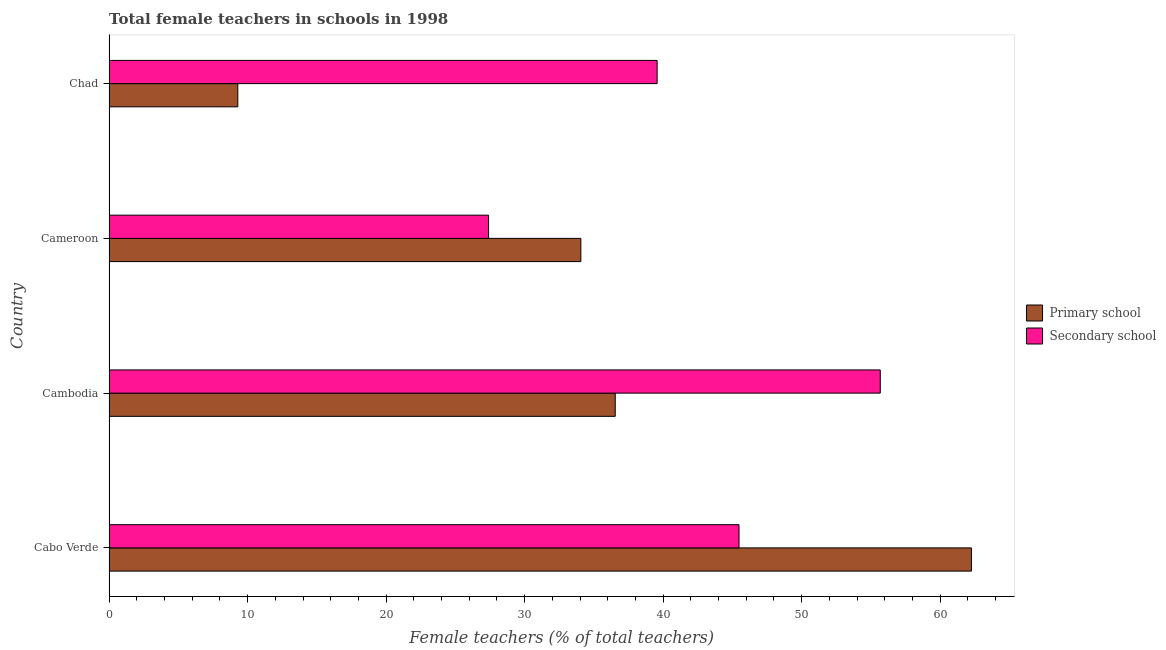Are the number of bars on each tick of the Y-axis equal?
Offer a very short reply. Yes. How many bars are there on the 2nd tick from the top?
Provide a short and direct response. 2. How many bars are there on the 3rd tick from the bottom?
Offer a very short reply. 2. What is the label of the 2nd group of bars from the top?
Your response must be concise. Cameroon. In how many cases, is the number of bars for a given country not equal to the number of legend labels?
Make the answer very short. 0. What is the percentage of female teachers in secondary schools in Cambodia?
Your response must be concise. 55.67. Across all countries, what is the maximum percentage of female teachers in primary schools?
Ensure brevity in your answer.  62.26. Across all countries, what is the minimum percentage of female teachers in secondary schools?
Offer a terse response. 27.4. In which country was the percentage of female teachers in secondary schools maximum?
Provide a short and direct response. Cambodia. In which country was the percentage of female teachers in secondary schools minimum?
Your answer should be very brief. Cameroon. What is the total percentage of female teachers in secondary schools in the graph?
Your answer should be compact. 168.12. What is the difference between the percentage of female teachers in primary schools in Cabo Verde and that in Cameroon?
Ensure brevity in your answer.  28.2. What is the difference between the percentage of female teachers in secondary schools in Chad and the percentage of female teachers in primary schools in Cabo Verde?
Keep it short and to the point. -22.69. What is the average percentage of female teachers in primary schools per country?
Give a very brief answer. 35.54. What is the difference between the percentage of female teachers in primary schools and percentage of female teachers in secondary schools in Cabo Verde?
Ensure brevity in your answer.  16.78. In how many countries, is the percentage of female teachers in primary schools greater than 14 %?
Offer a very short reply. 3. What is the ratio of the percentage of female teachers in secondary schools in Cabo Verde to that in Cambodia?
Provide a short and direct response. 0.82. Is the percentage of female teachers in primary schools in Cabo Verde less than that in Cambodia?
Give a very brief answer. No. What is the difference between the highest and the second highest percentage of female teachers in secondary schools?
Offer a very short reply. 10.2. What is the difference between the highest and the lowest percentage of female teachers in secondary schools?
Keep it short and to the point. 28.28. In how many countries, is the percentage of female teachers in primary schools greater than the average percentage of female teachers in primary schools taken over all countries?
Your answer should be very brief. 2. What does the 1st bar from the top in Cameroon represents?
Your response must be concise. Secondary school. What does the 2nd bar from the bottom in Cabo Verde represents?
Ensure brevity in your answer.  Secondary school. How many countries are there in the graph?
Keep it short and to the point. 4. What is the difference between two consecutive major ticks on the X-axis?
Provide a succinct answer. 10. Does the graph contain grids?
Give a very brief answer. No. Where does the legend appear in the graph?
Provide a succinct answer. Center right. How are the legend labels stacked?
Your answer should be compact. Vertical. What is the title of the graph?
Your answer should be very brief. Total female teachers in schools in 1998. Does "Borrowers" appear as one of the legend labels in the graph?
Ensure brevity in your answer.  No. What is the label or title of the X-axis?
Your answer should be compact. Female teachers (% of total teachers). What is the Female teachers (% of total teachers) of Primary school in Cabo Verde?
Offer a very short reply. 62.26. What is the Female teachers (% of total teachers) of Secondary school in Cabo Verde?
Your answer should be very brief. 45.48. What is the Female teachers (% of total teachers) in Primary school in Cambodia?
Provide a short and direct response. 36.54. What is the Female teachers (% of total teachers) of Secondary school in Cambodia?
Provide a succinct answer. 55.67. What is the Female teachers (% of total teachers) in Primary school in Cameroon?
Your answer should be very brief. 34.06. What is the Female teachers (% of total teachers) of Secondary school in Cameroon?
Provide a short and direct response. 27.4. What is the Female teachers (% of total teachers) in Primary school in Chad?
Give a very brief answer. 9.29. What is the Female teachers (% of total teachers) of Secondary school in Chad?
Keep it short and to the point. 39.57. Across all countries, what is the maximum Female teachers (% of total teachers) in Primary school?
Offer a terse response. 62.26. Across all countries, what is the maximum Female teachers (% of total teachers) in Secondary school?
Offer a terse response. 55.67. Across all countries, what is the minimum Female teachers (% of total teachers) of Primary school?
Your answer should be very brief. 9.29. Across all countries, what is the minimum Female teachers (% of total teachers) in Secondary school?
Make the answer very short. 27.4. What is the total Female teachers (% of total teachers) in Primary school in the graph?
Ensure brevity in your answer.  142.15. What is the total Female teachers (% of total teachers) of Secondary school in the graph?
Offer a very short reply. 168.12. What is the difference between the Female teachers (% of total teachers) in Primary school in Cabo Verde and that in Cambodia?
Give a very brief answer. 25.71. What is the difference between the Female teachers (% of total teachers) of Secondary school in Cabo Verde and that in Cambodia?
Your answer should be compact. -10.2. What is the difference between the Female teachers (% of total teachers) in Primary school in Cabo Verde and that in Cameroon?
Offer a very short reply. 28.2. What is the difference between the Female teachers (% of total teachers) of Secondary school in Cabo Verde and that in Cameroon?
Give a very brief answer. 18.08. What is the difference between the Female teachers (% of total teachers) in Primary school in Cabo Verde and that in Chad?
Your response must be concise. 52.96. What is the difference between the Female teachers (% of total teachers) of Secondary school in Cabo Verde and that in Chad?
Make the answer very short. 5.91. What is the difference between the Female teachers (% of total teachers) in Primary school in Cambodia and that in Cameroon?
Offer a very short reply. 2.48. What is the difference between the Female teachers (% of total teachers) in Secondary school in Cambodia and that in Cameroon?
Make the answer very short. 28.28. What is the difference between the Female teachers (% of total teachers) of Primary school in Cambodia and that in Chad?
Make the answer very short. 27.25. What is the difference between the Female teachers (% of total teachers) of Secondary school in Cambodia and that in Chad?
Your answer should be compact. 16.11. What is the difference between the Female teachers (% of total teachers) in Primary school in Cameroon and that in Chad?
Make the answer very short. 24.77. What is the difference between the Female teachers (% of total teachers) of Secondary school in Cameroon and that in Chad?
Your answer should be compact. -12.17. What is the difference between the Female teachers (% of total teachers) in Primary school in Cabo Verde and the Female teachers (% of total teachers) in Secondary school in Cambodia?
Provide a succinct answer. 6.58. What is the difference between the Female teachers (% of total teachers) in Primary school in Cabo Verde and the Female teachers (% of total teachers) in Secondary school in Cameroon?
Your answer should be compact. 34.86. What is the difference between the Female teachers (% of total teachers) in Primary school in Cabo Verde and the Female teachers (% of total teachers) in Secondary school in Chad?
Provide a succinct answer. 22.69. What is the difference between the Female teachers (% of total teachers) of Primary school in Cambodia and the Female teachers (% of total teachers) of Secondary school in Cameroon?
Make the answer very short. 9.14. What is the difference between the Female teachers (% of total teachers) in Primary school in Cambodia and the Female teachers (% of total teachers) in Secondary school in Chad?
Offer a terse response. -3.03. What is the difference between the Female teachers (% of total teachers) in Primary school in Cameroon and the Female teachers (% of total teachers) in Secondary school in Chad?
Offer a terse response. -5.51. What is the average Female teachers (% of total teachers) in Primary school per country?
Offer a terse response. 35.54. What is the average Female teachers (% of total teachers) in Secondary school per country?
Make the answer very short. 42.03. What is the difference between the Female teachers (% of total teachers) of Primary school and Female teachers (% of total teachers) of Secondary school in Cabo Verde?
Offer a very short reply. 16.78. What is the difference between the Female teachers (% of total teachers) of Primary school and Female teachers (% of total teachers) of Secondary school in Cambodia?
Keep it short and to the point. -19.13. What is the difference between the Female teachers (% of total teachers) in Primary school and Female teachers (% of total teachers) in Secondary school in Cameroon?
Provide a succinct answer. 6.66. What is the difference between the Female teachers (% of total teachers) in Primary school and Female teachers (% of total teachers) in Secondary school in Chad?
Ensure brevity in your answer.  -30.27. What is the ratio of the Female teachers (% of total teachers) in Primary school in Cabo Verde to that in Cambodia?
Offer a terse response. 1.7. What is the ratio of the Female teachers (% of total teachers) in Secondary school in Cabo Verde to that in Cambodia?
Ensure brevity in your answer.  0.82. What is the ratio of the Female teachers (% of total teachers) of Primary school in Cabo Verde to that in Cameroon?
Provide a succinct answer. 1.83. What is the ratio of the Female teachers (% of total teachers) of Secondary school in Cabo Verde to that in Cameroon?
Your response must be concise. 1.66. What is the ratio of the Female teachers (% of total teachers) in Primary school in Cabo Verde to that in Chad?
Ensure brevity in your answer.  6.7. What is the ratio of the Female teachers (% of total teachers) of Secondary school in Cabo Verde to that in Chad?
Offer a terse response. 1.15. What is the ratio of the Female teachers (% of total teachers) in Primary school in Cambodia to that in Cameroon?
Provide a short and direct response. 1.07. What is the ratio of the Female teachers (% of total teachers) in Secondary school in Cambodia to that in Cameroon?
Offer a terse response. 2.03. What is the ratio of the Female teachers (% of total teachers) of Primary school in Cambodia to that in Chad?
Offer a very short reply. 3.93. What is the ratio of the Female teachers (% of total teachers) of Secondary school in Cambodia to that in Chad?
Offer a terse response. 1.41. What is the ratio of the Female teachers (% of total teachers) of Primary school in Cameroon to that in Chad?
Make the answer very short. 3.66. What is the ratio of the Female teachers (% of total teachers) in Secondary school in Cameroon to that in Chad?
Provide a short and direct response. 0.69. What is the difference between the highest and the second highest Female teachers (% of total teachers) of Primary school?
Keep it short and to the point. 25.71. What is the difference between the highest and the second highest Female teachers (% of total teachers) of Secondary school?
Keep it short and to the point. 10.2. What is the difference between the highest and the lowest Female teachers (% of total teachers) of Primary school?
Offer a terse response. 52.96. What is the difference between the highest and the lowest Female teachers (% of total teachers) of Secondary school?
Your response must be concise. 28.28. 